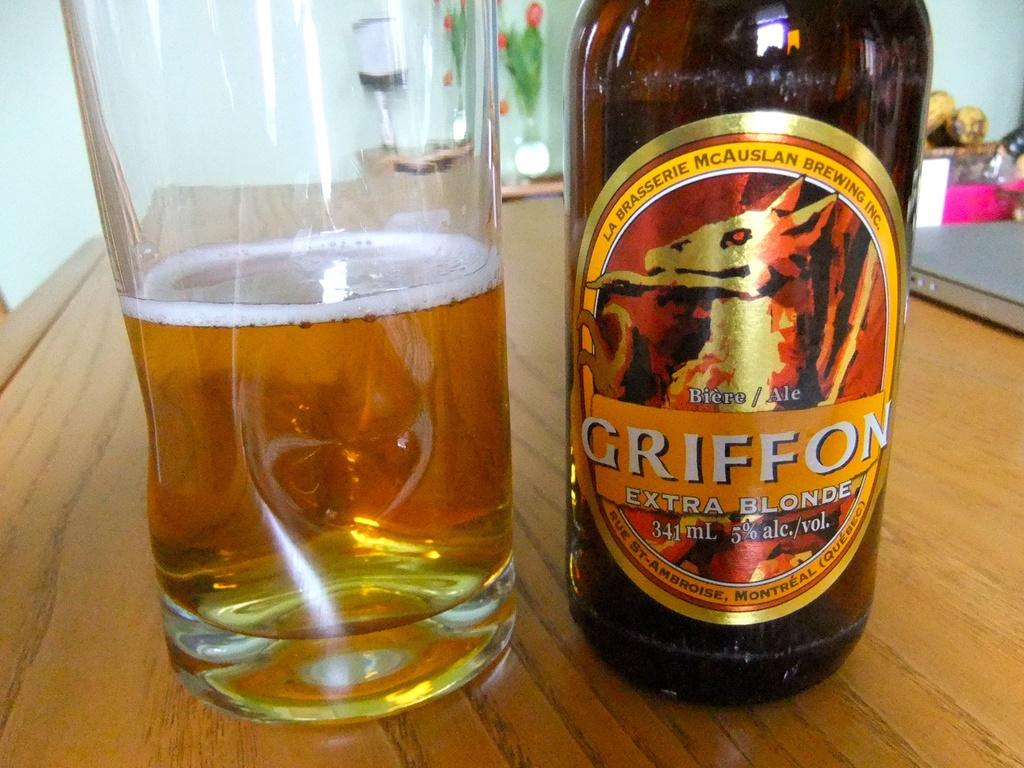<image>
Summarize the visual content of the image. A bottle of Griffon Extra Blonde beer is next to a glass half full of beer. 